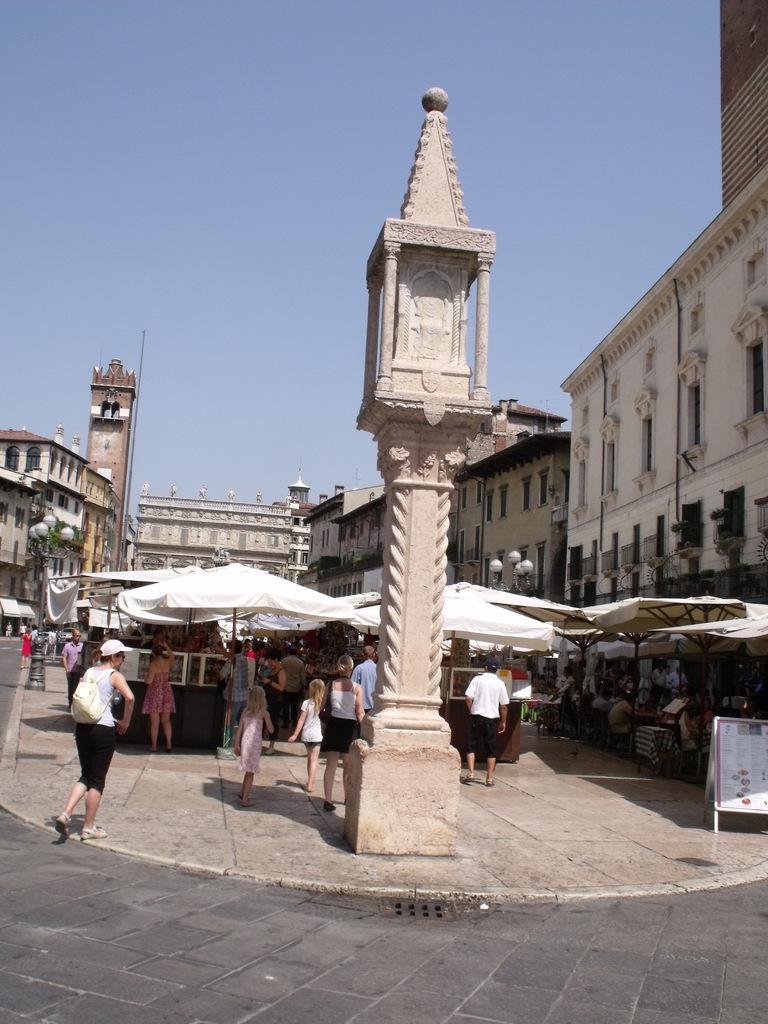Describe this image in one or two sentences. In this image there are group of persons walking and standing. In the background there are buildings, poles. In the front there is a pole. Behind the pole there are tents which are white in colour. Under the tent there are persons. On the right side there are buildings and in front of the building there are persons sitting. 